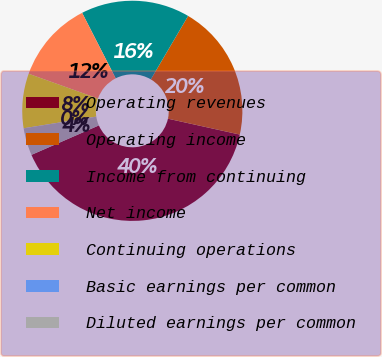Convert chart. <chart><loc_0><loc_0><loc_500><loc_500><pie_chart><fcel>Operating revenues<fcel>Operating income<fcel>Income from continuing<fcel>Net income<fcel>Continuing operations<fcel>Basic earnings per common<fcel>Diluted earnings per common<nl><fcel>39.99%<fcel>20.0%<fcel>16.0%<fcel>12.0%<fcel>8.0%<fcel>0.01%<fcel>4.01%<nl></chart> 